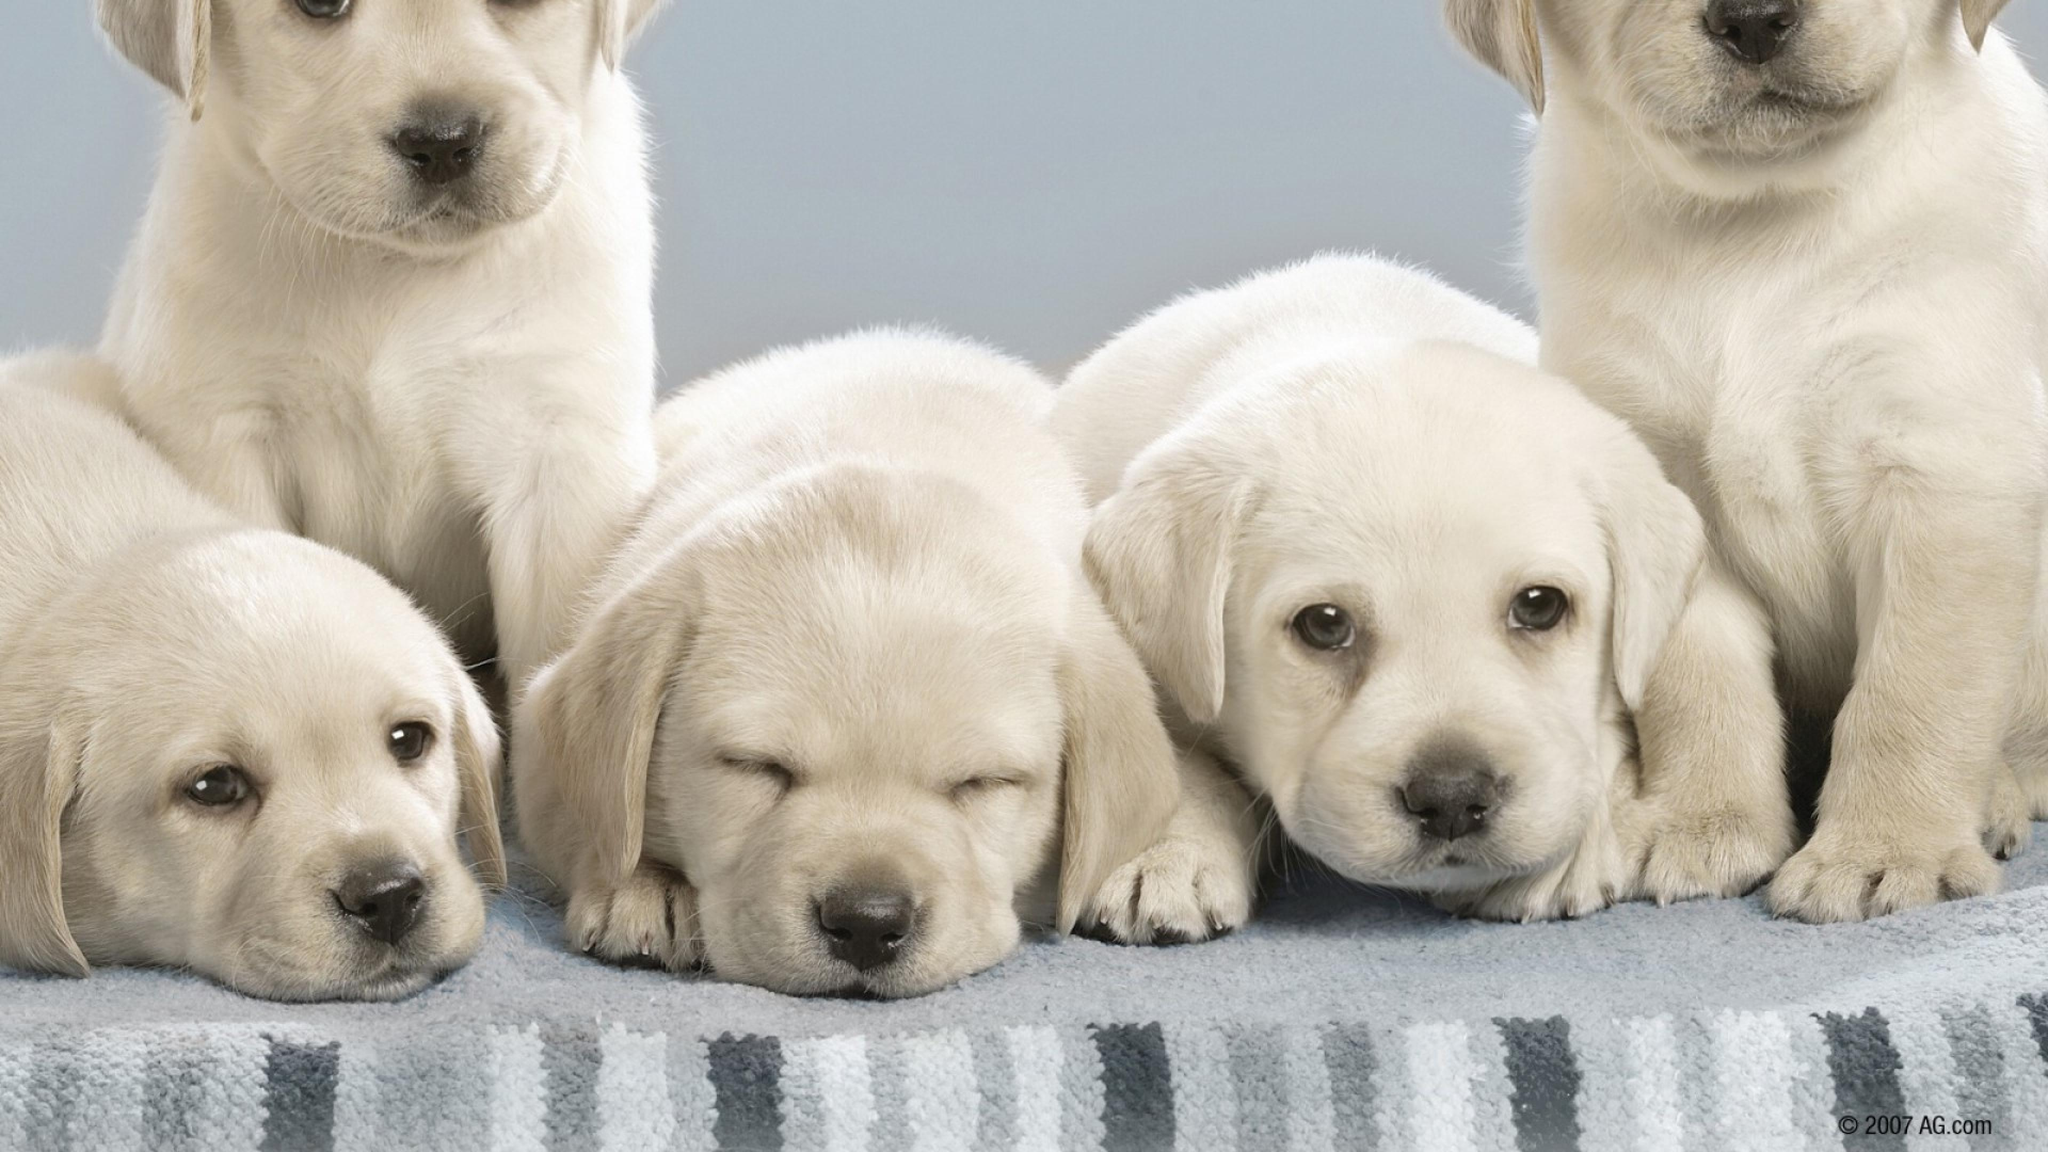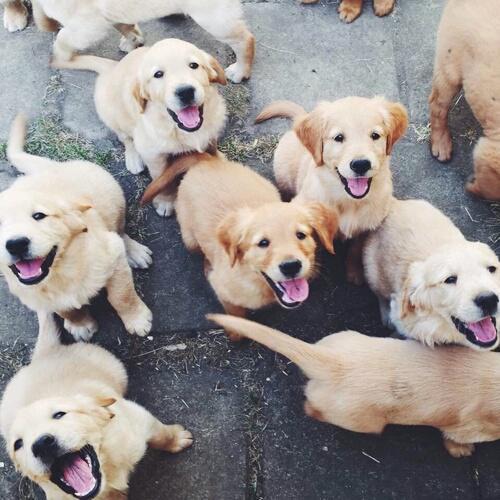The first image is the image on the left, the second image is the image on the right. Examine the images to the left and right. Is the description "In one image, a puppy is leaning over a wooden ledge with only its head and front paws visible." accurate? Answer yes or no. No. The first image is the image on the left, the second image is the image on the right. For the images shown, is this caption "In 1 of the images, 1 dog is leaning over the edge of a wooden box." true? Answer yes or no. No. 